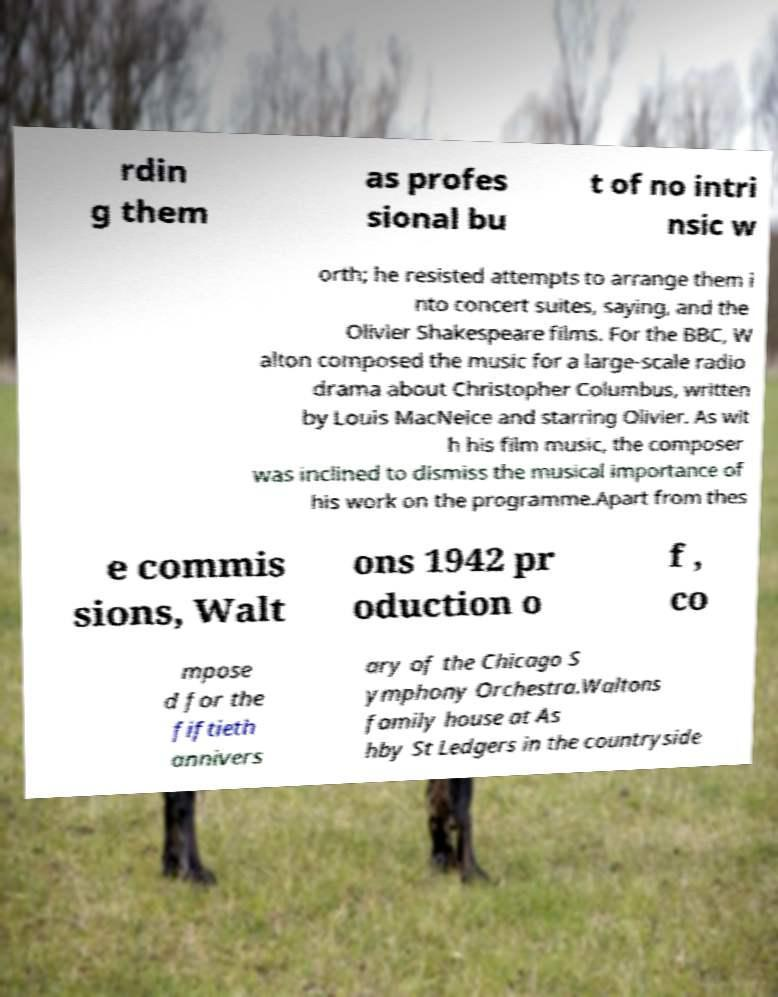For documentation purposes, I need the text within this image transcribed. Could you provide that? rdin g them as profes sional bu t of no intri nsic w orth; he resisted attempts to arrange them i nto concert suites, saying, and the Olivier Shakespeare films. For the BBC, W alton composed the music for a large-scale radio drama about Christopher Columbus, written by Louis MacNeice and starring Olivier. As wit h his film music, the composer was inclined to dismiss the musical importance of his work on the programme.Apart from thes e commis sions, Walt ons 1942 pr oduction o f , co mpose d for the fiftieth annivers ary of the Chicago S ymphony Orchestra.Waltons family house at As hby St Ledgers in the countryside 